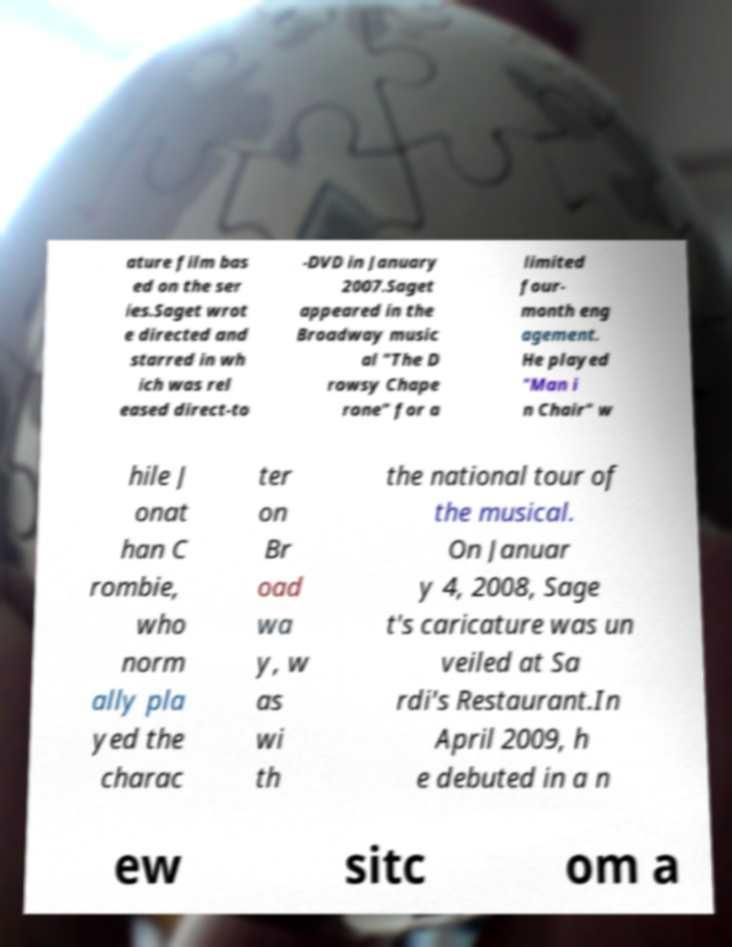Can you accurately transcribe the text from the provided image for me? ature film bas ed on the ser ies.Saget wrot e directed and starred in wh ich was rel eased direct-to -DVD in January 2007.Saget appeared in the Broadway music al "The D rowsy Chape rone" for a limited four- month eng agement. He played "Man i n Chair" w hile J onat han C rombie, who norm ally pla yed the charac ter on Br oad wa y, w as wi th the national tour of the musical. On Januar y 4, 2008, Sage t's caricature was un veiled at Sa rdi's Restaurant.In April 2009, h e debuted in a n ew sitc om a 